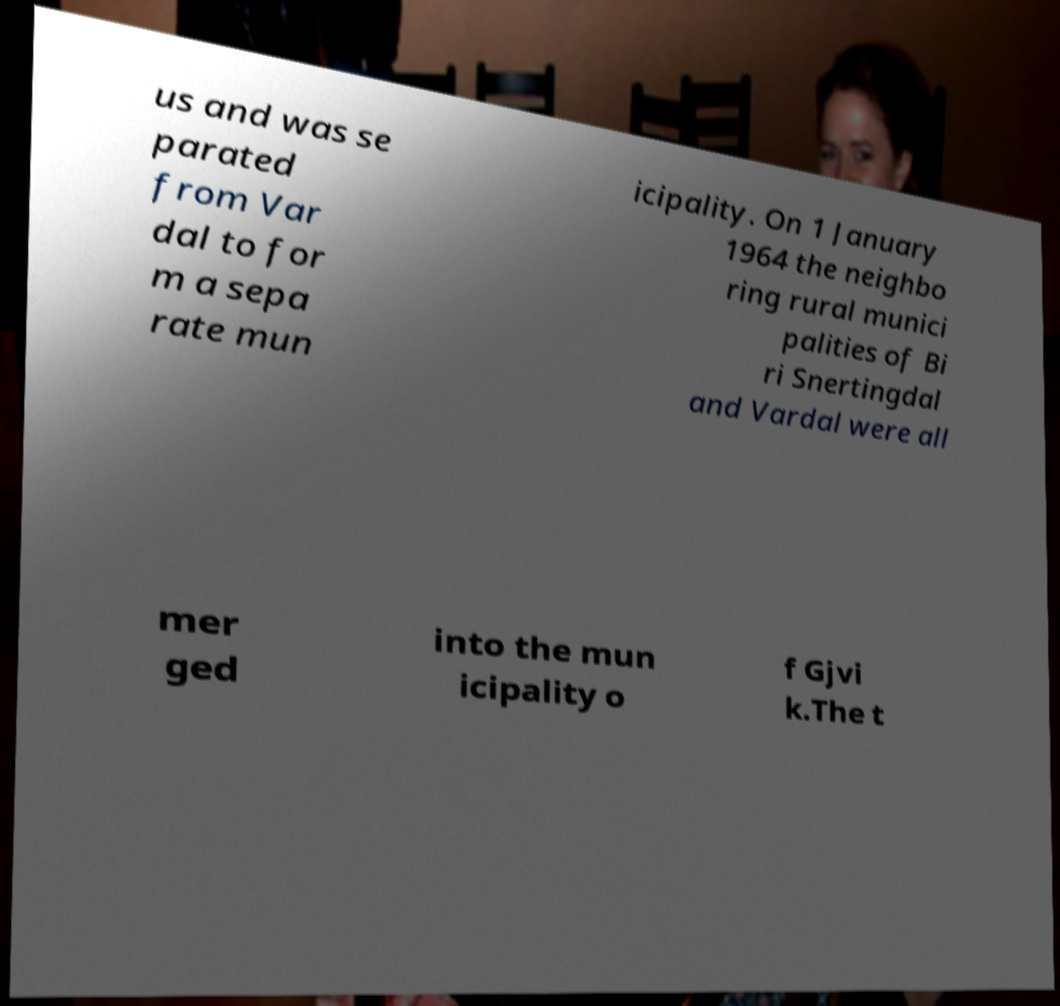Could you assist in decoding the text presented in this image and type it out clearly? us and was se parated from Var dal to for m a sepa rate mun icipality. On 1 January 1964 the neighbo ring rural munici palities of Bi ri Snertingdal and Vardal were all mer ged into the mun icipality o f Gjvi k.The t 